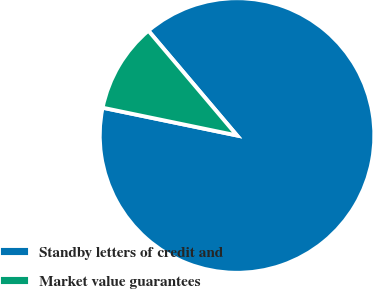Convert chart to OTSL. <chart><loc_0><loc_0><loc_500><loc_500><pie_chart><fcel>Standby letters of credit and<fcel>Market value guarantees<nl><fcel>89.42%<fcel>10.58%<nl></chart> 